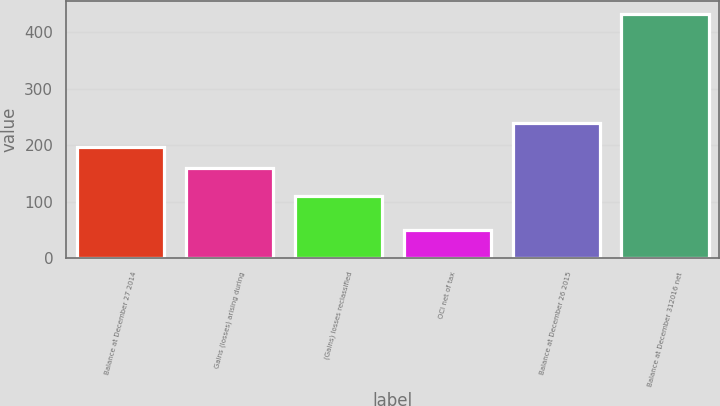Convert chart to OTSL. <chart><loc_0><loc_0><loc_500><loc_500><bar_chart><fcel>Balance at December 27 2014<fcel>Gains (losses) arising during<fcel>(Gains) losses reclassified<fcel>OCI net of tax<fcel>Balance at December 26 2015<fcel>Balance at December 312016 net<nl><fcel>197.4<fcel>159<fcel>110<fcel>49<fcel>239<fcel>433<nl></chart> 